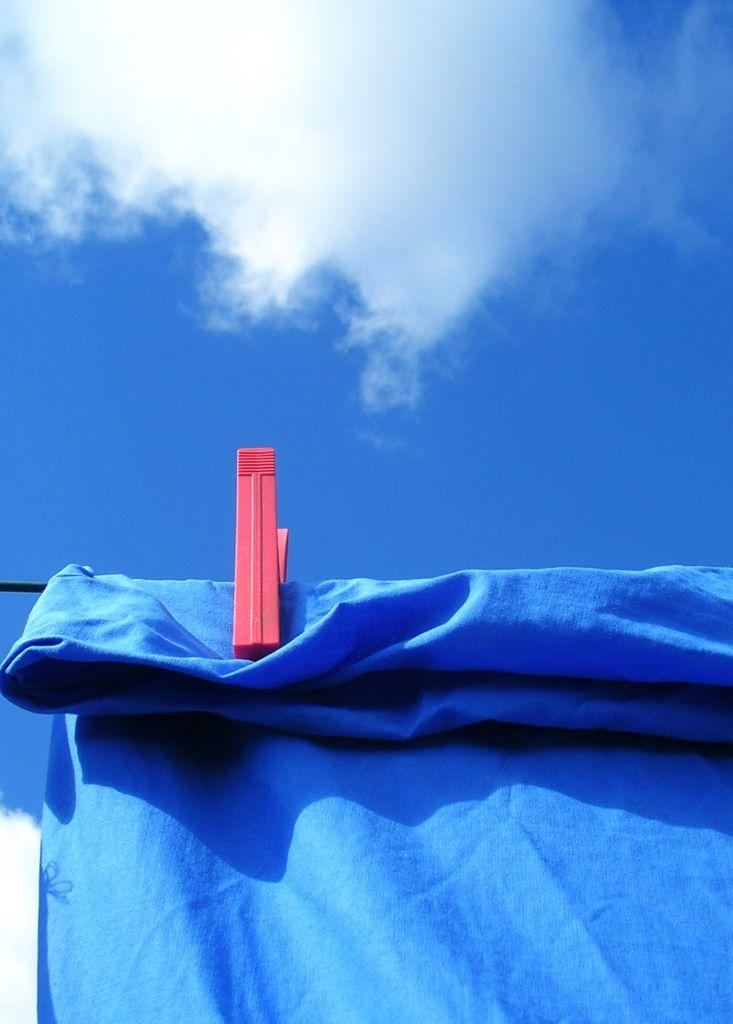What is hanging on a rope in the image? There is a cloth hanging on a rope in the image. What can be seen in the middle of the image? There is a clip in the middle of the image. What is visible in the sky in the image? There is a cloud visible in the sky. What type of stocking is hanging on the rope in the image? There is no stocking present in the image; it is a cloth hanging on a rope. What type of cable is visible in the image? There is no cable present in the image; the only visible object related to a rope is the cloth hanging on it. 